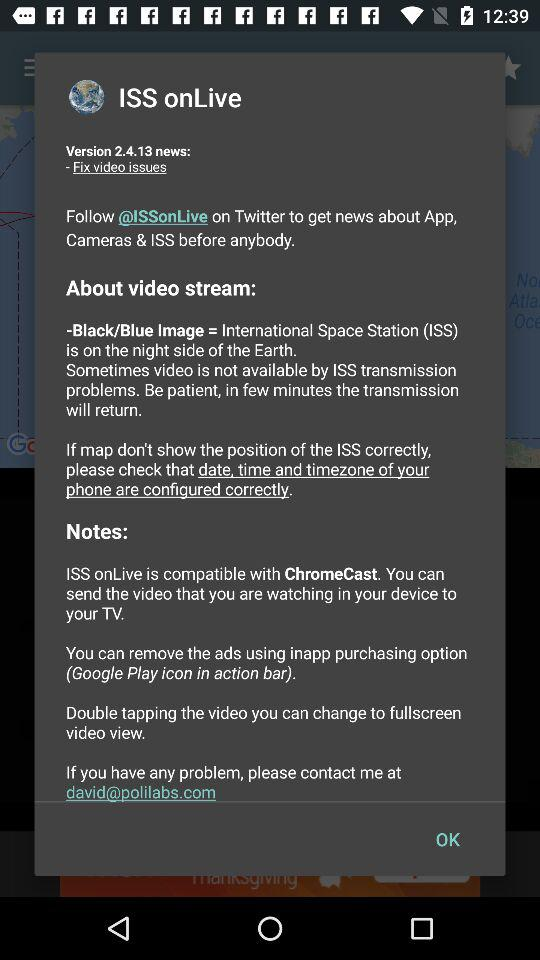Which version is mentioned? The mentioned version is 2.4.13. 